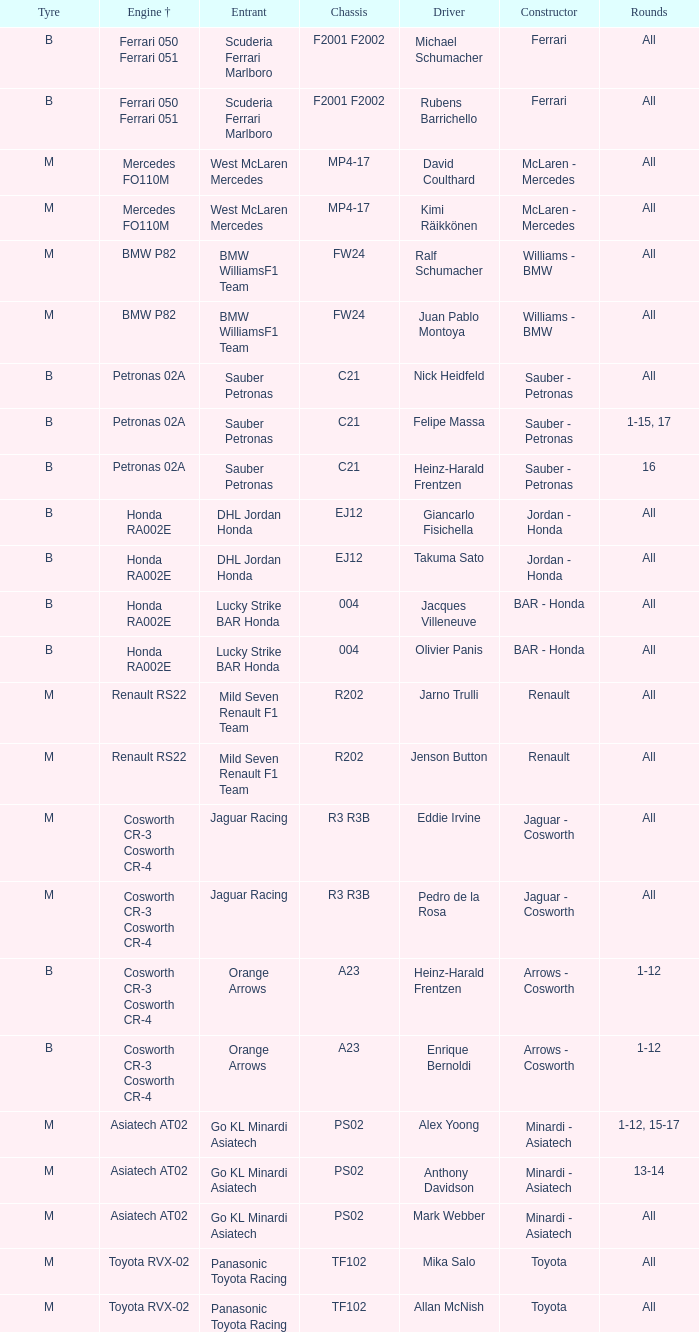What is the chassis when the tyre is b, the engine is ferrari 050 ferrari 051 and the driver is rubens barrichello? F2001 F2002. 